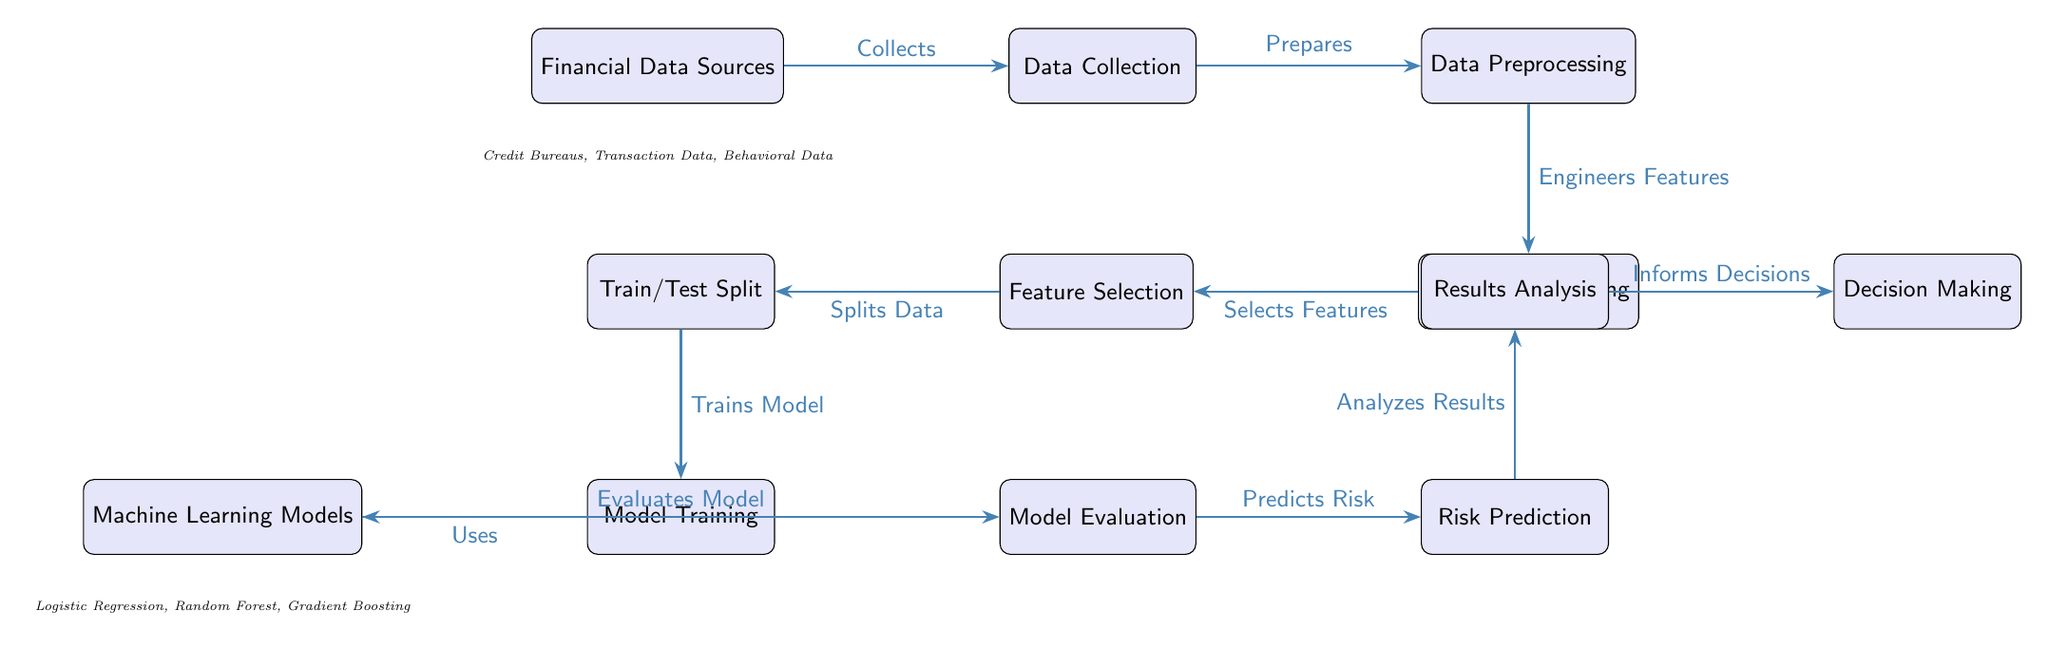What are the entities represented in the "Financial Data Sources" node? The "Financial Data Sources" node includes entities such as Credit Bureaus, Transaction Data, and Behavioral Data, which are noted below the node in the diagram.
Answer: Credit Bureaus, Transaction Data, Behavioral Data What is the first process following data collection? According to the diagram, after "Data Collection," the next step is "Data Preprocessing," which is indicated by the directed arrow leading from the "Data Collection" node to the "Data Preprocessing" node.
Answer: Data Preprocessing Which machine learning models are used in the training phase? The diagram lists "Logistic Regression," "Random Forest," and "Gradient Boosting" as the machine learning models employed during the modeling process. These models are mentioned below the "Machine Learning Models" node.
Answer: Logistic Regression, Random Forest, Gradient Boosting What type of flow does this diagram represent? The flow depicted in this diagram represents a sequential process that outlines the stages of credit risk assessment using machine learning, showing how each phase leads to the next in a step-by-step manner.
Answer: Sequential Process What action does the "Model Evaluation" node perform? The "Model Evaluation" node is responsible for evaluating model performance, as indicated by the label on the arrow leading to this node from the "Machine Learning Models" node.
Answer: Evaluates Model What are the final decisions informed by in this diagram? The diagram indicates that "Decision Making" is informed by the results analyzed in the "Results Analysis" step, demonstrated by the arrow connecting these two nodes.
Answer: Results Analysis How many main nodes are involved in the credit risk assessment process? The diagram consists of ten main nodes, which can be counted from the start node "Financial Data Sources" to the end node "Decision Making."
Answer: Ten What happens after "Risk Prediction"? The step following "Risk Prediction" is "Results Analysis," as shown in the diagram. This indicates a flow that incorporates the prediction results into subsequent analysis.
Answer: Results Analysis What is the role of "Feature Selection" in the process? The "Feature Selection" node plays a critical role in selecting relevant features from the engineered features that can then be used in model training. This is shown in the diagram by its position in the workflow and labeling.
Answer: Selects Features 